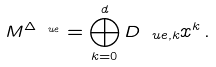Convert formula to latex. <formula><loc_0><loc_0><loc_500><loc_500>M ^ { \Delta _ { \ u e } } = \bigoplus _ { k = 0 } ^ { d } D _ { \ u e , k } x ^ { k } \, .</formula> 